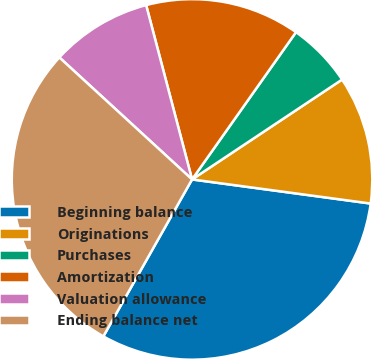<chart> <loc_0><loc_0><loc_500><loc_500><pie_chart><fcel>Beginning balance<fcel>Originations<fcel>Purchases<fcel>Amortization<fcel>Valuation allowance<fcel>Ending balance net<nl><fcel>31.05%<fcel>11.48%<fcel>5.87%<fcel>13.88%<fcel>9.07%<fcel>28.64%<nl></chart> 